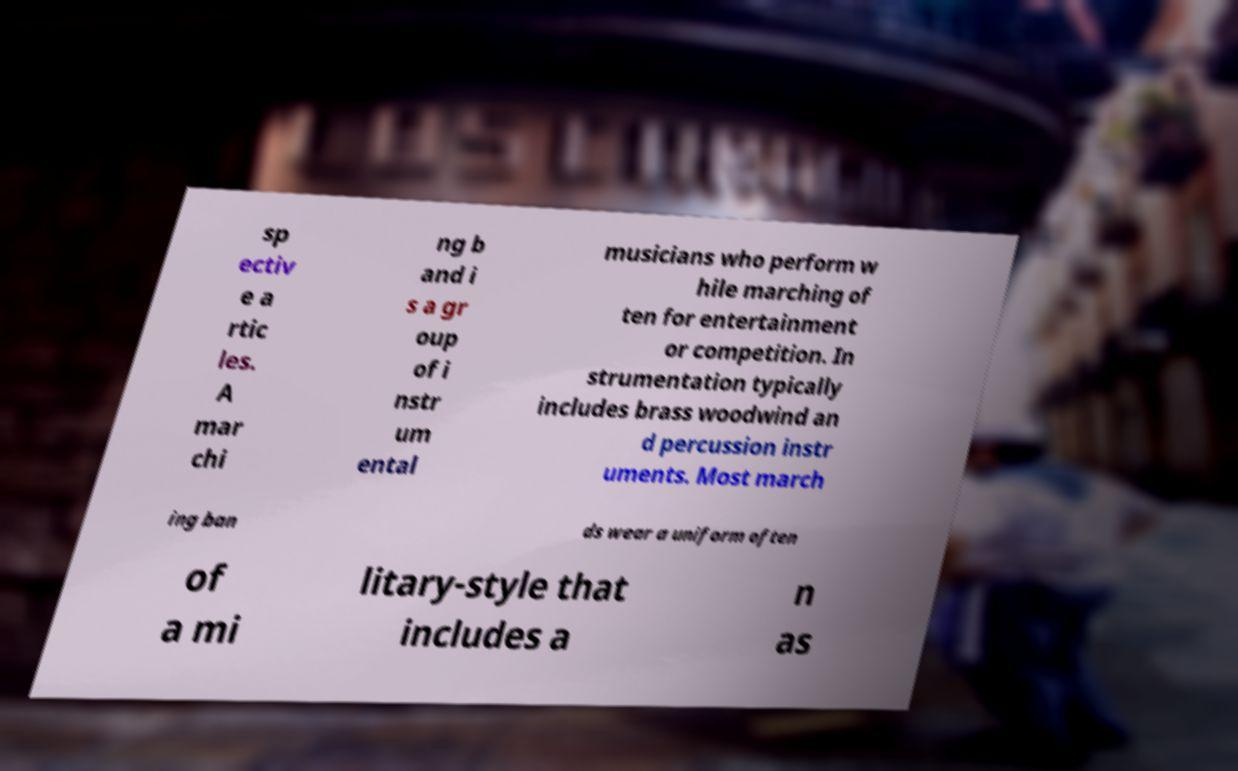There's text embedded in this image that I need extracted. Can you transcribe it verbatim? sp ectiv e a rtic les. A mar chi ng b and i s a gr oup of i nstr um ental musicians who perform w hile marching of ten for entertainment or competition. In strumentation typically includes brass woodwind an d percussion instr uments. Most march ing ban ds wear a uniform often of a mi litary-style that includes a n as 